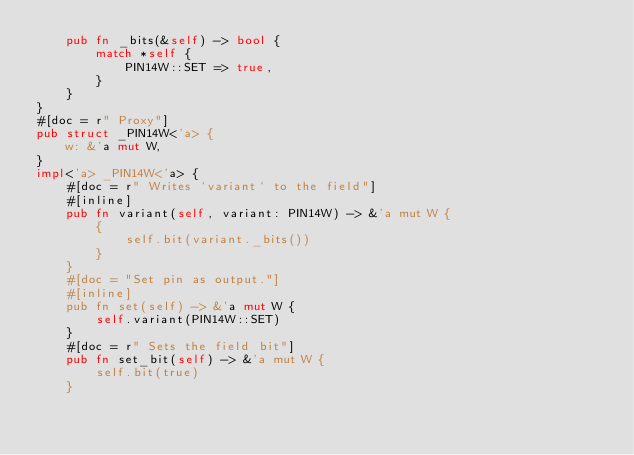Convert code to text. <code><loc_0><loc_0><loc_500><loc_500><_Rust_>    pub fn _bits(&self) -> bool {
        match *self {
            PIN14W::SET => true,
        }
    }
}
#[doc = r" Proxy"]
pub struct _PIN14W<'a> {
    w: &'a mut W,
}
impl<'a> _PIN14W<'a> {
    #[doc = r" Writes `variant` to the field"]
    #[inline]
    pub fn variant(self, variant: PIN14W) -> &'a mut W {
        {
            self.bit(variant._bits())
        }
    }
    #[doc = "Set pin as output."]
    #[inline]
    pub fn set(self) -> &'a mut W {
        self.variant(PIN14W::SET)
    }
    #[doc = r" Sets the field bit"]
    pub fn set_bit(self) -> &'a mut W {
        self.bit(true)
    }</code> 